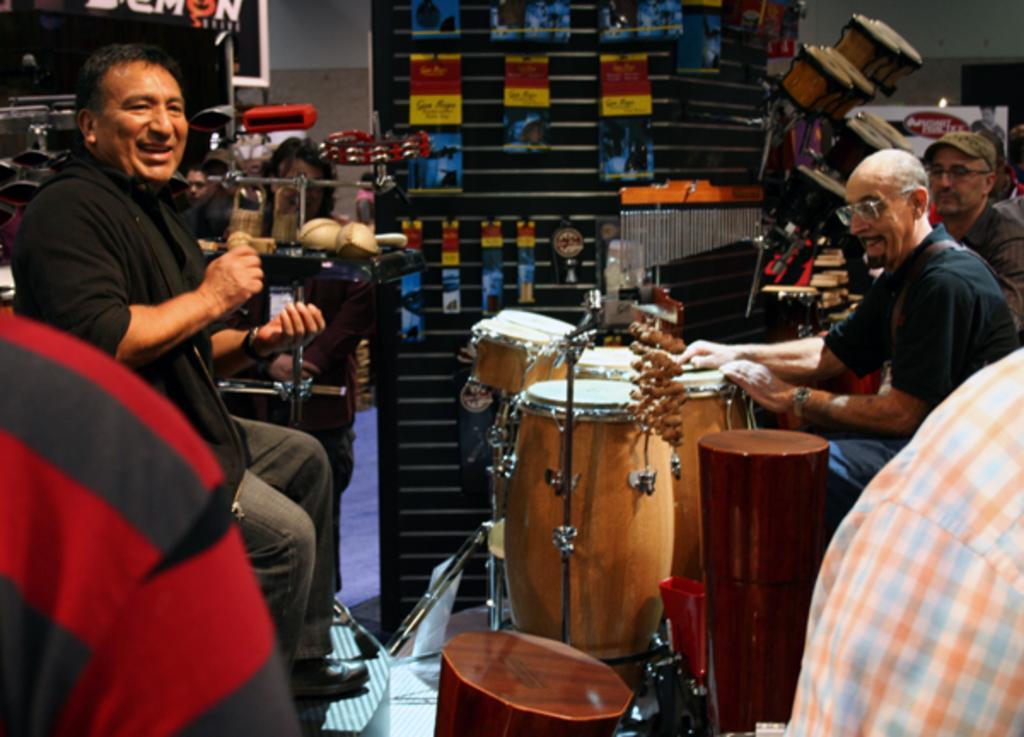How would you summarize this image in a sentence or two? In the image we can see there are people who are sitting on chair and they are playing musical instruments. 